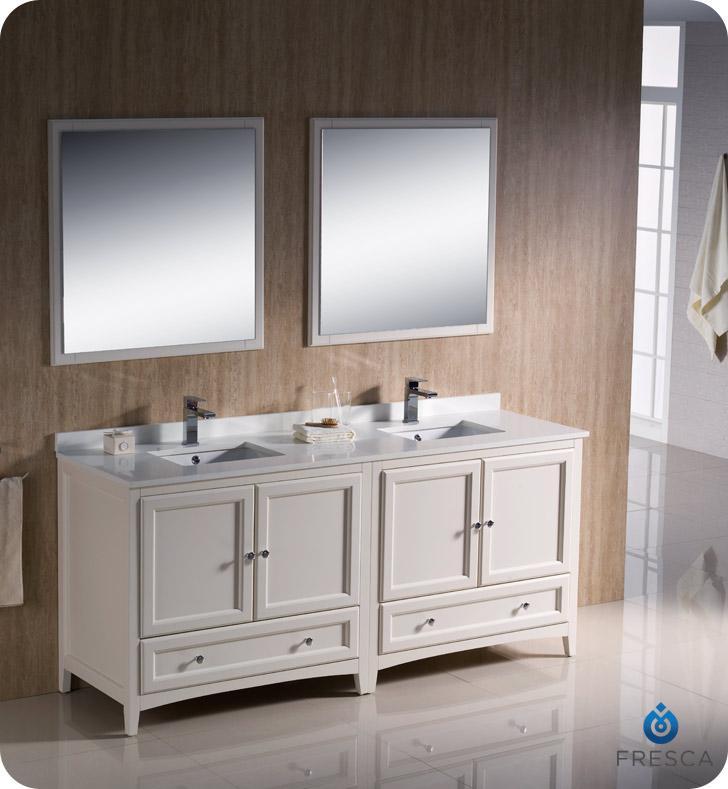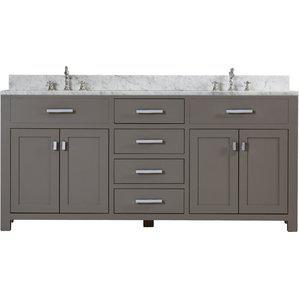The first image is the image on the left, the second image is the image on the right. Assess this claim about the two images: "At least one image shows a pair of mirrors over a double vanity with the bottom of its cabinet open and holding towels.". Correct or not? Answer yes or no. No. The first image is the image on the left, the second image is the image on the right. Considering the images on both sides, is "One of the sink vanities does not have a double mirror above it." valid? Answer yes or no. Yes. 